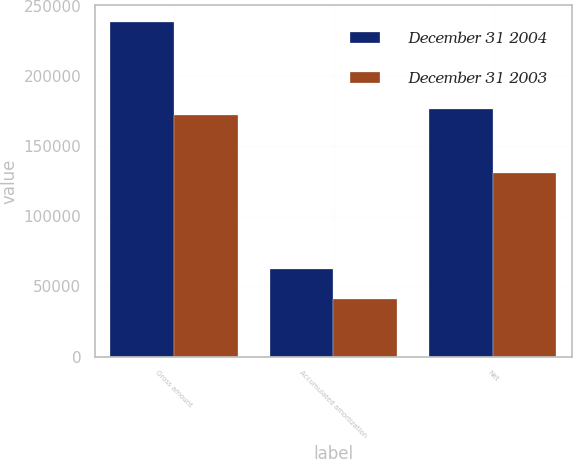Convert chart to OTSL. <chart><loc_0><loc_0><loc_500><loc_500><stacked_bar_chart><ecel><fcel>Gross amount<fcel>Accumulated amortization<fcel>Net<nl><fcel>December 31 2004<fcel>238428<fcel>62114<fcel>176314<nl><fcel>December 31 2003<fcel>171842<fcel>40967<fcel>130875<nl></chart> 